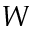Convert formula to latex. <formula><loc_0><loc_0><loc_500><loc_500>W</formula> 